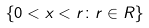<formula> <loc_0><loc_0><loc_500><loc_500>\{ 0 < x < r \colon r \in R \}</formula> 